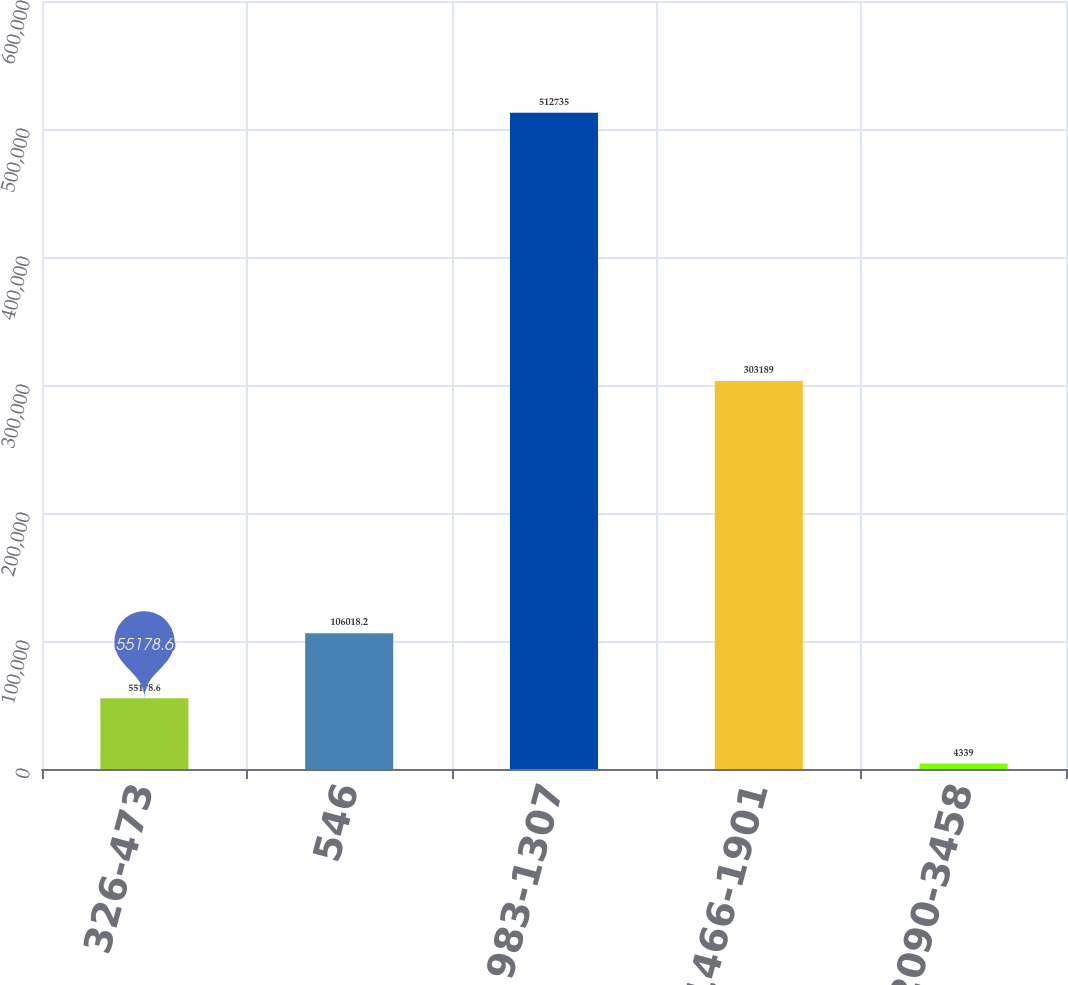Convert chart. <chart><loc_0><loc_0><loc_500><loc_500><bar_chart><fcel>326-473<fcel>546<fcel>983-1307<fcel>1466-1901<fcel>2090-3458<nl><fcel>55178.6<fcel>106018<fcel>512735<fcel>303189<fcel>4339<nl></chart> 